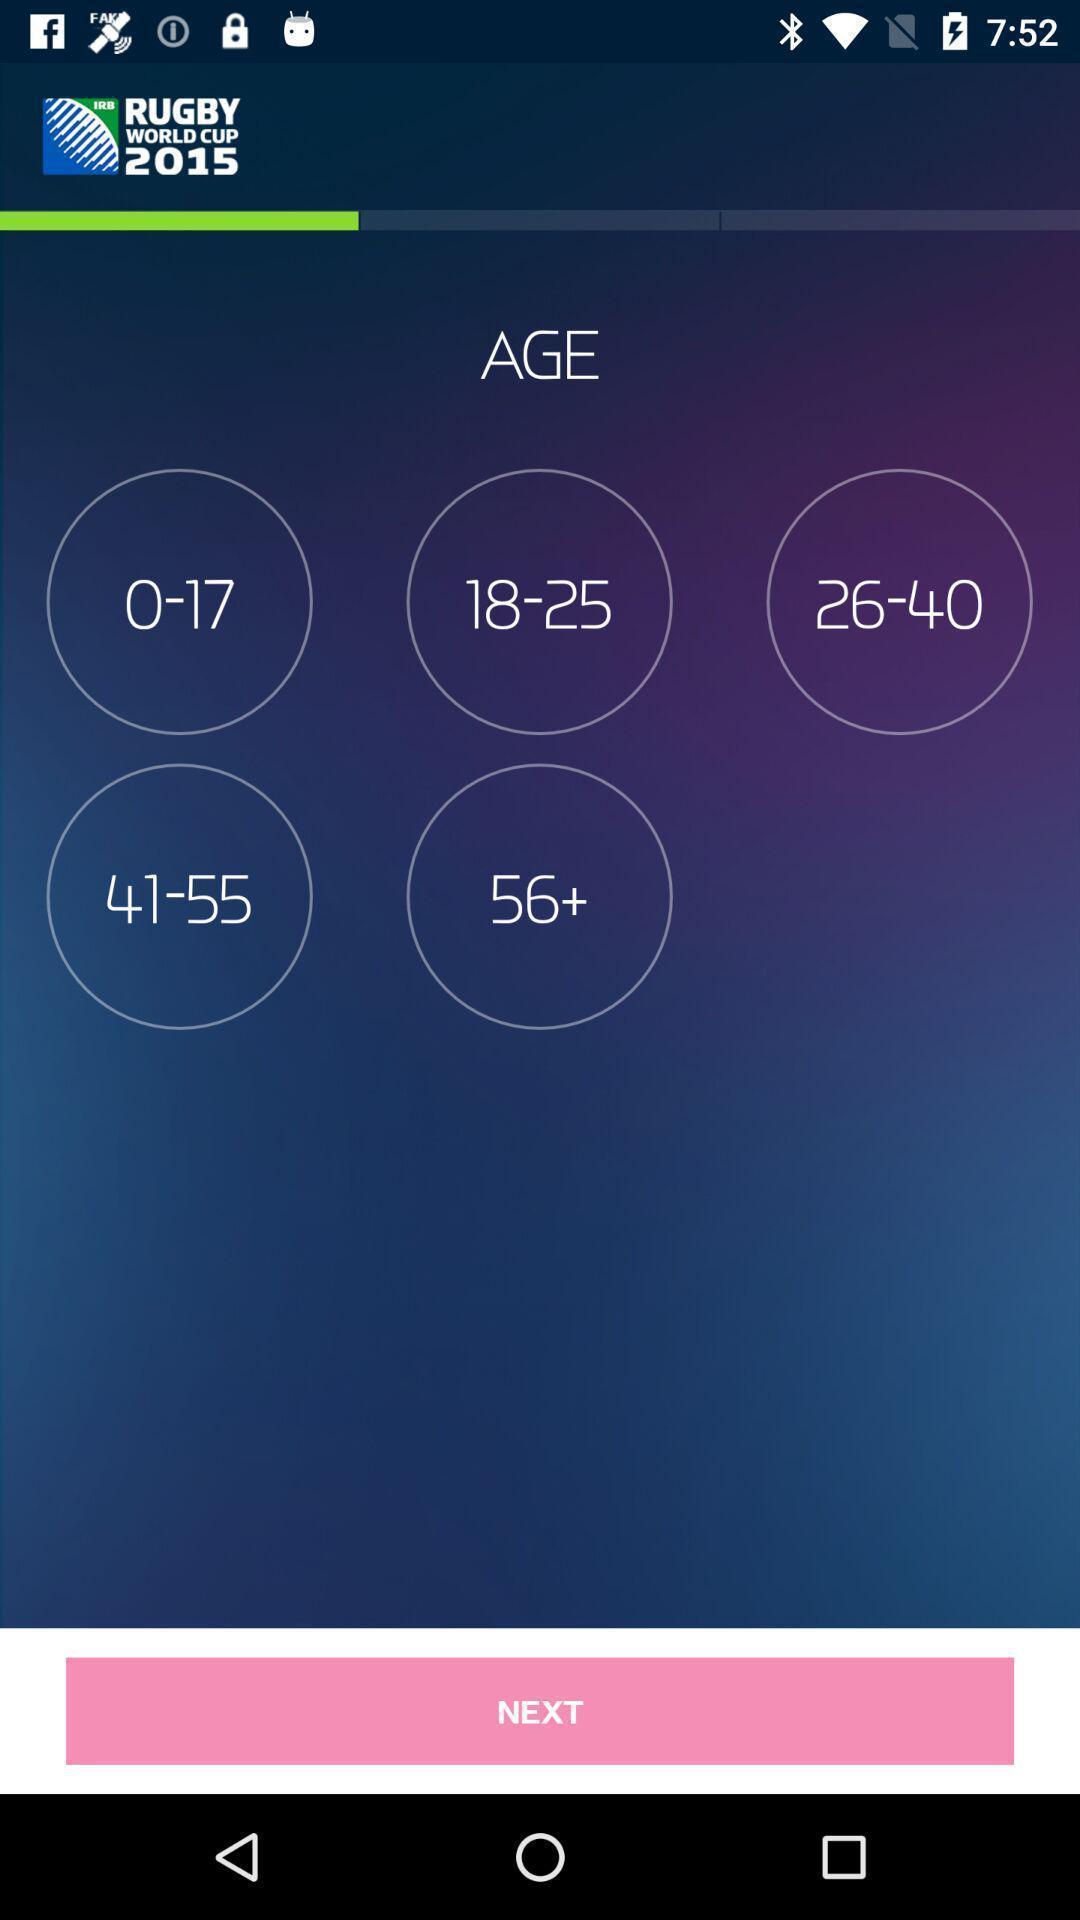Describe this image in words. Page to select the age criteria. 